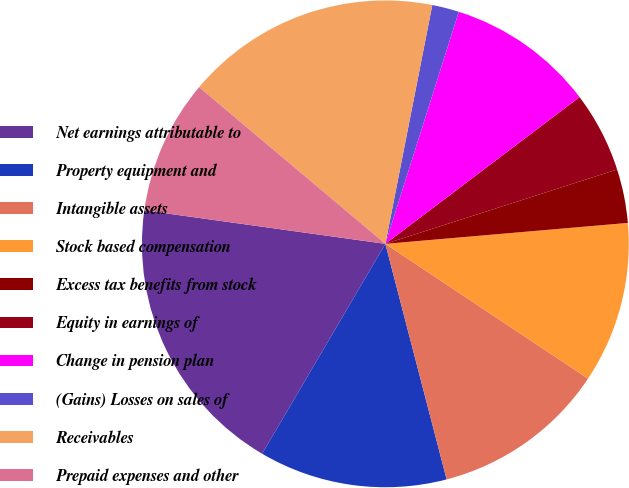Convert chart. <chart><loc_0><loc_0><loc_500><loc_500><pie_chart><fcel>Net earnings attributable to<fcel>Property equipment and<fcel>Intangible assets<fcel>Stock based compensation<fcel>Excess tax benefits from stock<fcel>Equity in earnings of<fcel>Change in pension plan<fcel>(Gains) Losses on sales of<fcel>Receivables<fcel>Prepaid expenses and other<nl><fcel>18.75%<fcel>12.5%<fcel>11.61%<fcel>10.71%<fcel>3.57%<fcel>5.36%<fcel>9.82%<fcel>1.79%<fcel>16.96%<fcel>8.93%<nl></chart> 